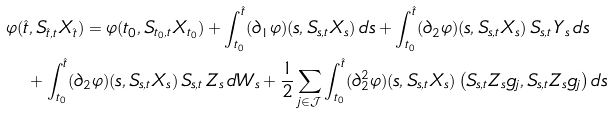<formula> <loc_0><loc_0><loc_500><loc_500>& \varphi ( \hat { t } , S _ { \hat { t } , t } X _ { \hat { t } } ) = \varphi ( t _ { 0 } , S _ { t _ { 0 } , t } X _ { t _ { 0 } } ) + \int _ { t _ { 0 } } ^ { \hat { t } } ( \partial _ { 1 } \varphi ) ( s , S _ { s , t } X _ { s } ) \, d s + \int _ { t _ { 0 } } ^ { \hat { t } } ( \partial _ { 2 } \varphi ) ( s , S _ { s , t } X _ { s } ) \, S _ { s , t } \, Y _ { s } \, d s \\ & \quad + \int _ { t _ { 0 } } ^ { \hat { t } } ( \partial _ { 2 } \varphi ) ( s , S _ { s , t } X _ { s } ) \, S _ { s , t } \, Z _ { s } \, d W _ { s } + \frac { 1 } { 2 } \sum _ { j \in \mathcal { J } } \int _ { t _ { 0 } } ^ { \hat { t } } ( \partial _ { 2 } ^ { 2 } \varphi ) ( s , S _ { s , t } X _ { s } ) \left ( S _ { s , t } Z _ { s } g _ { j } , S _ { s , t } Z _ { s } g _ { j } \right ) d s</formula> 